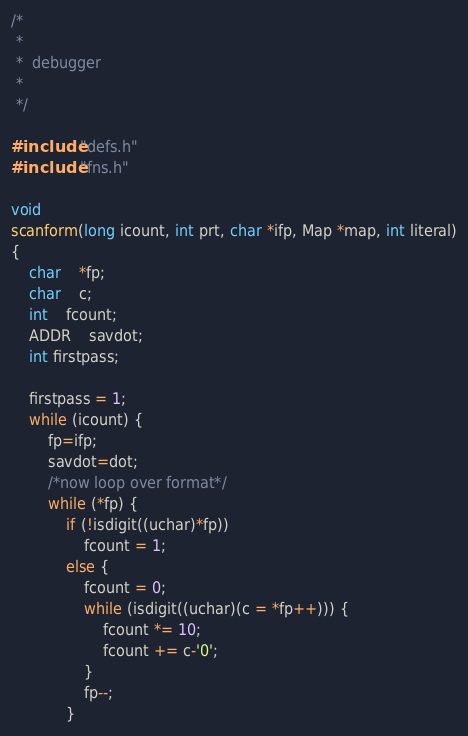Convert code to text. <code><loc_0><loc_0><loc_500><loc_500><_C_>/*
 *
 *	debugger
 *
 */

#include "defs.h"
#include "fns.h"

void
scanform(long icount, int prt, char *ifp, Map *map, int literal)
{
	char	*fp;
	char	c;
	int	fcount;
	ADDR	savdot;
	int firstpass;

	firstpass = 1;
	while (icount) {
		fp=ifp;
		savdot=dot;
		/*now loop over format*/
		while (*fp) {
			if (!isdigit((uchar)*fp))
				fcount = 1;
			else {
				fcount = 0;
				while (isdigit((uchar)(c = *fp++))) {
					fcount *= 10;
					fcount += c-'0';
				}
				fp--;
			}</code> 